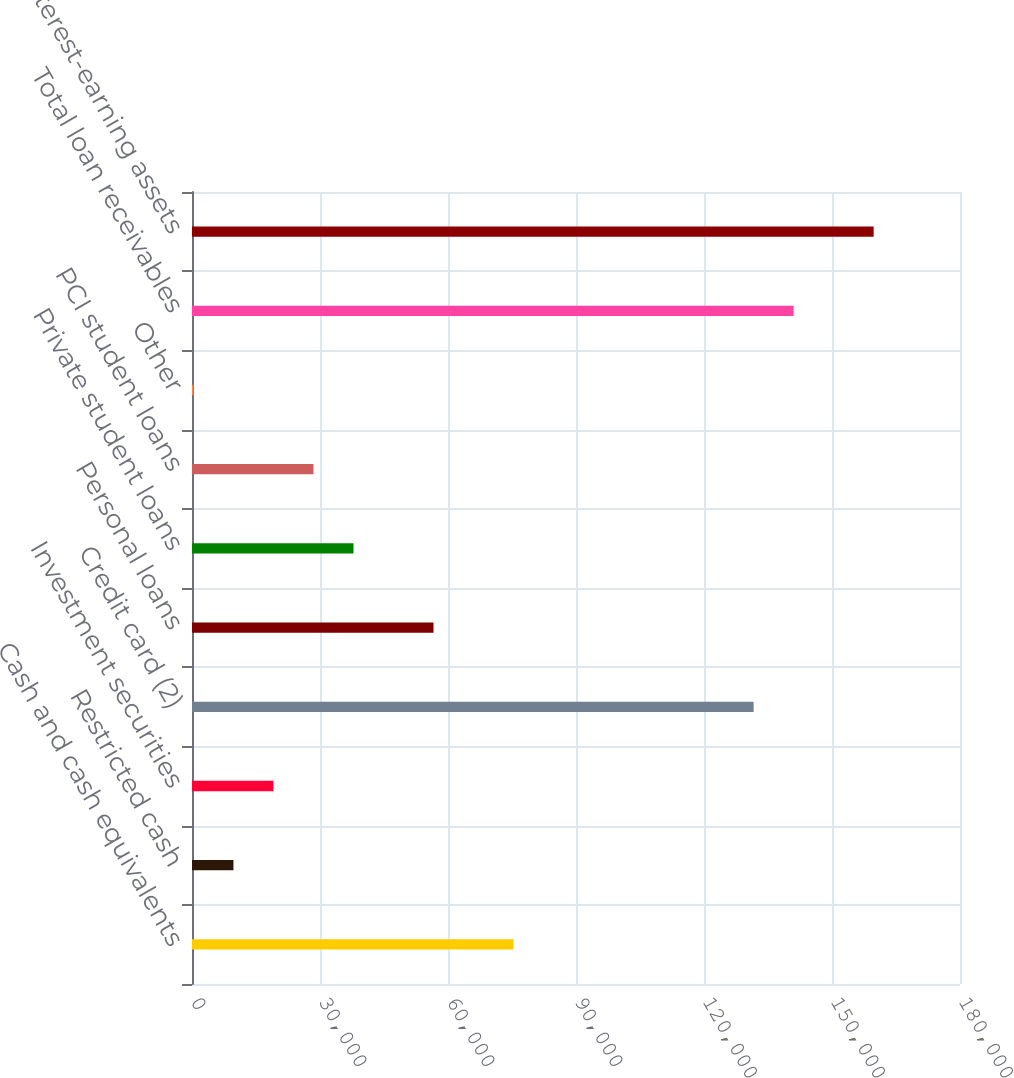Convert chart to OTSL. <chart><loc_0><loc_0><loc_500><loc_500><bar_chart><fcel>Cash and cash equivalents<fcel>Restricted cash<fcel>Investment securities<fcel>Credit card (2)<fcel>Personal loans<fcel>Private student loans<fcel>PCI student loans<fcel>Other<fcel>Total loan receivables<fcel>Total interest-earning assets<nl><fcel>75360.8<fcel>9714.1<fcel>19092.2<fcel>131629<fcel>56604.6<fcel>37848.4<fcel>28470.3<fcel>336<fcel>141008<fcel>159764<nl></chart> 